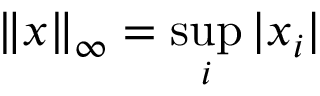Convert formula to latex. <formula><loc_0><loc_0><loc_500><loc_500>\| x \| _ { \infty } = \sup _ { i } | x _ { i } |</formula> 